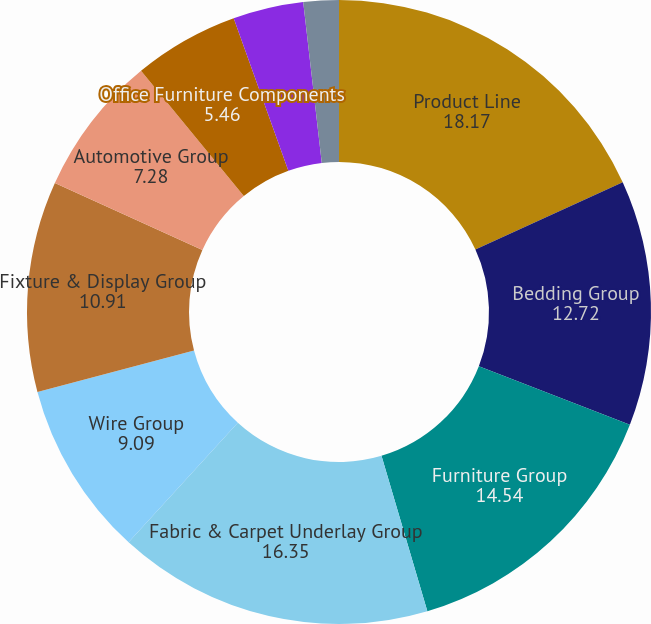Convert chart to OTSL. <chart><loc_0><loc_0><loc_500><loc_500><pie_chart><fcel>Product Line<fcel>Bedding Group<fcel>Furniture Group<fcel>Fabric & Carpet Underlay Group<fcel>Wire Group<fcel>Fixture & Display Group<fcel>Automotive Group<fcel>Office Furniture Components<fcel>Commercial Vehicle Products<fcel>Machinery Group<nl><fcel>18.17%<fcel>12.72%<fcel>14.54%<fcel>16.35%<fcel>9.09%<fcel>10.91%<fcel>7.28%<fcel>5.46%<fcel>3.65%<fcel>1.83%<nl></chart> 